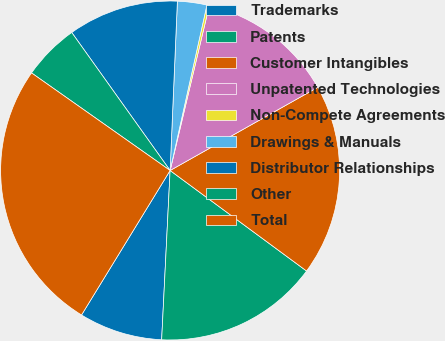Convert chart to OTSL. <chart><loc_0><loc_0><loc_500><loc_500><pie_chart><fcel>Trademarks<fcel>Patents<fcel>Customer Intangibles<fcel>Unpatented Technologies<fcel>Non-Compete Agreements<fcel>Drawings & Manuals<fcel>Distributor Relationships<fcel>Other<fcel>Total<nl><fcel>7.96%<fcel>15.69%<fcel>18.27%<fcel>13.12%<fcel>0.23%<fcel>2.8%<fcel>10.54%<fcel>5.38%<fcel>26.01%<nl></chart> 